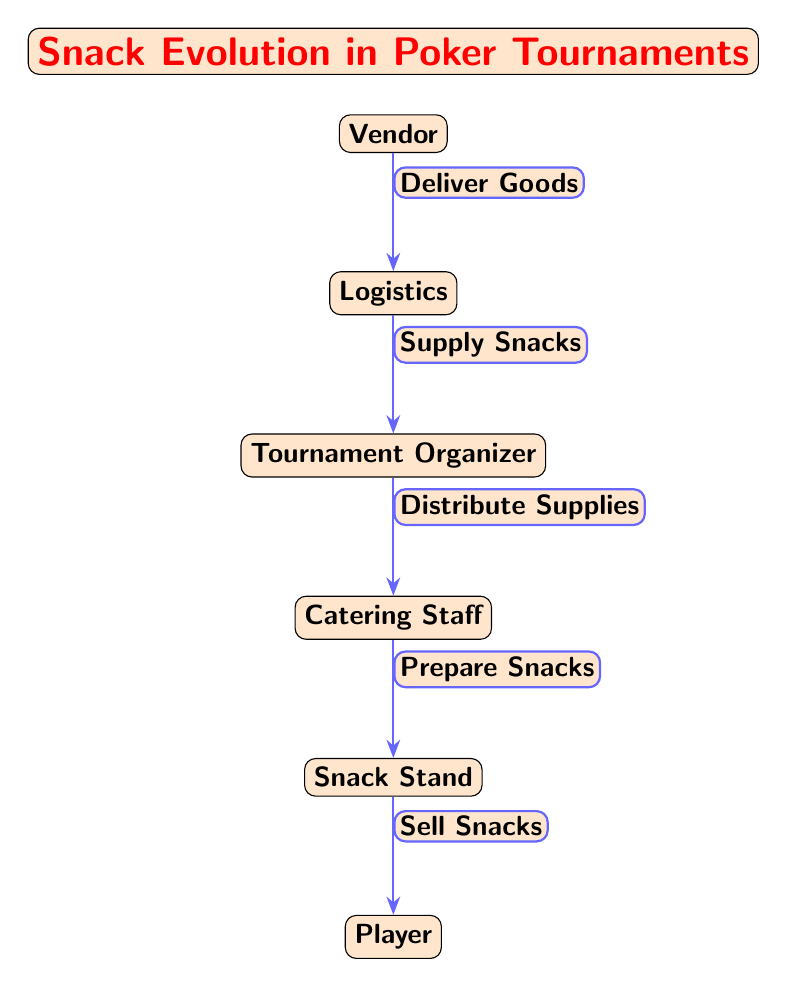What is the starting point of the snack evolution in the diagram? The starting point of the snack evolution is the 'Vendor' node, which is at the top of the diagram. This indicates that vendors are the initial contributors in the snack supply chain for poker tournaments.
Answer: Vendor How many nodes are there in total in the diagram? The diagram consists of six distinct nodes: Vendor, Logistics, Tournament Organizer, Catering Staff, Snack Stand, and Player. By counting each of these, we arrive at a total of six nodes.
Answer: 6 What process comes before the 'Snack Stand' in the snack evolution? The process that comes immediately before 'Snack Stand' is 'Catering Staff', which prepares the snacks that will eventually be sold at the snack stand.
Answer: Catering Staff Which role is responsible for 'Sell Snacks'? The role responsible for 'Sell Snacks' is the 'Player', indicating that players are the final recipients of the snacks within the tournament setting.
Answer: Player What is the function that connects 'Organizer' to 'Catering Staff'? The function connecting 'Organizer' to 'Catering Staff' is 'Distribute Supplies', which shows that the organizer manages the distribution of supplied goods to the catering team.
Answer: Distribute Supplies Which node is directly below the 'Logistics' node? The node that is directly below the 'Logistics' node is the 'Tournament Organizer', indicating a flow from logistics to tournament management.
Answer: Tournament Organizer If 'Organizer' were to not function properly, which node would be most affected? If the 'Organizer' does not function properly, the most affected node would be 'Catering Staff', as the organizer's role is crucial for distributing supplies to the catering team for snack preparation.
Answer: Catering Staff What does the 'Vendor' do in this diagram? In this diagram, the 'Vendor' is responsible for delivering goods to logistics, serving as the initial source of snacks for the tournament.
Answer: Deliver Goods What is the interaction between 'Catering Staff' and 'Snack Stand'? The interaction is that 'Catering Staff' prepares snacks which are then sold by the 'Snack Stand', showing the flow from preparation to sale.
Answer: Prepare Snacks 